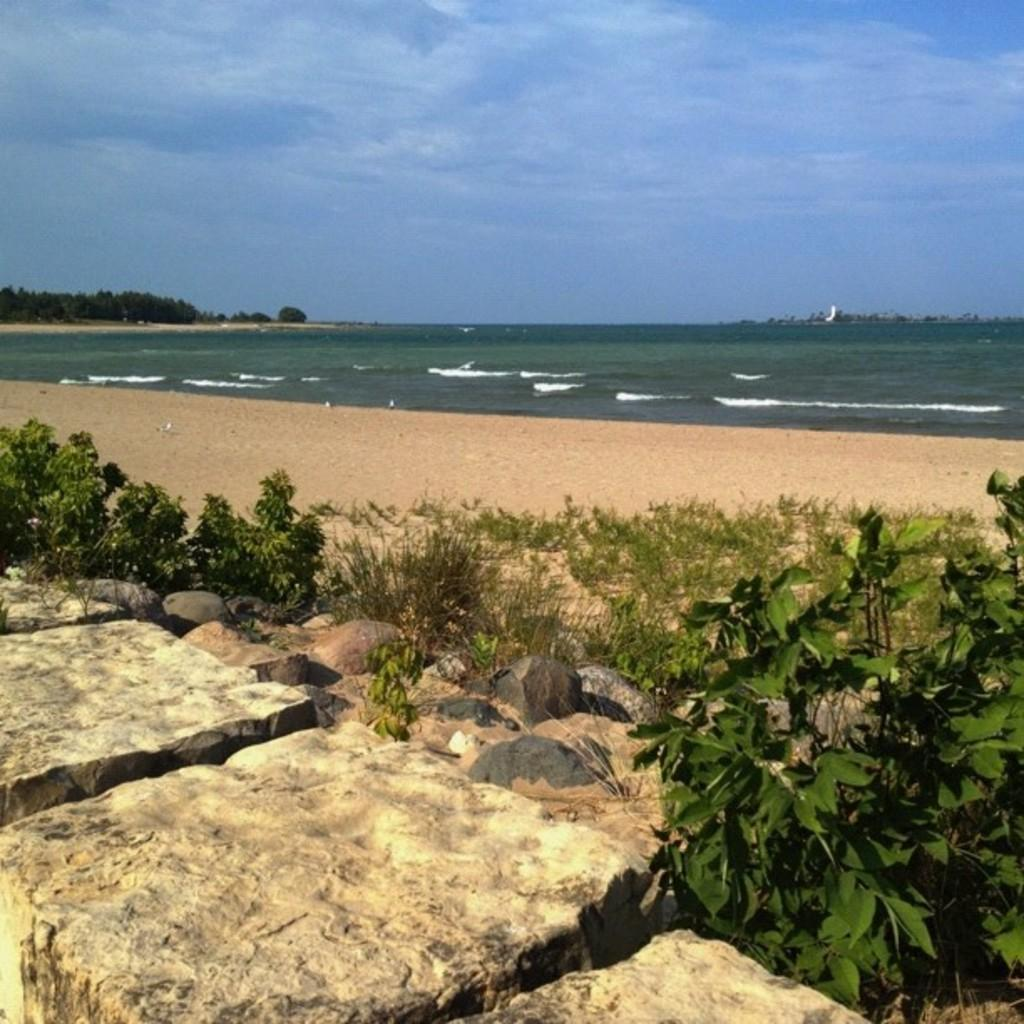What natural feature is the main subject of the image? The image contains the ocean. What other elements can be seen in the image besides the ocean? There are trees and plants, stones, and the sky visible in the image. What is the condition of the sky in the image? The sky is visible at the top of the image, and clouds are present in the sky. What type of treatment can be seen being applied to the ocean in the image? There is no treatment being applied to the ocean in the image; it is a natural scene with no human intervention. 